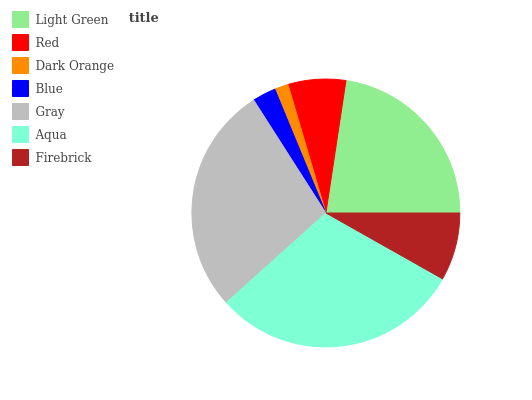Is Dark Orange the minimum?
Answer yes or no. Yes. Is Aqua the maximum?
Answer yes or no. Yes. Is Red the minimum?
Answer yes or no. No. Is Red the maximum?
Answer yes or no. No. Is Light Green greater than Red?
Answer yes or no. Yes. Is Red less than Light Green?
Answer yes or no. Yes. Is Red greater than Light Green?
Answer yes or no. No. Is Light Green less than Red?
Answer yes or no. No. Is Firebrick the high median?
Answer yes or no. Yes. Is Firebrick the low median?
Answer yes or no. Yes. Is Blue the high median?
Answer yes or no. No. Is Red the low median?
Answer yes or no. No. 